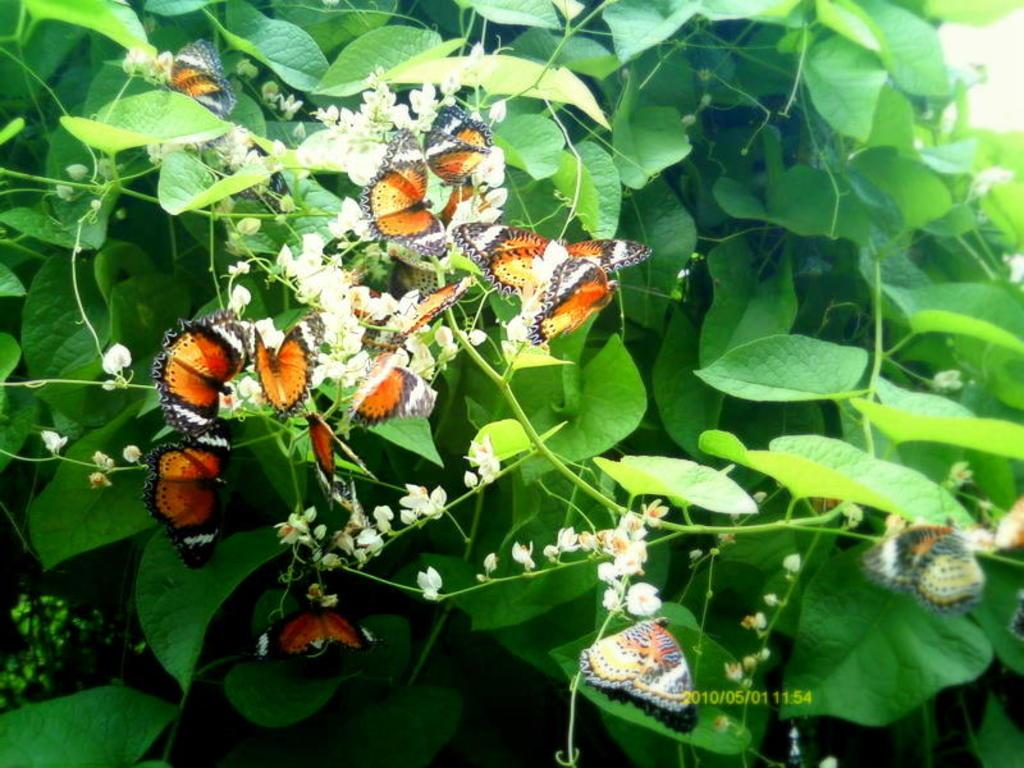What type of animals can be seen in the image? Birds can be seen in the image. What type of vegetation is present in the image? There are leaves in the image. What type of fuel is being used by the sneezing bird in the image? There is no bird sneezing in the image, and therefore no fuel is being used. 